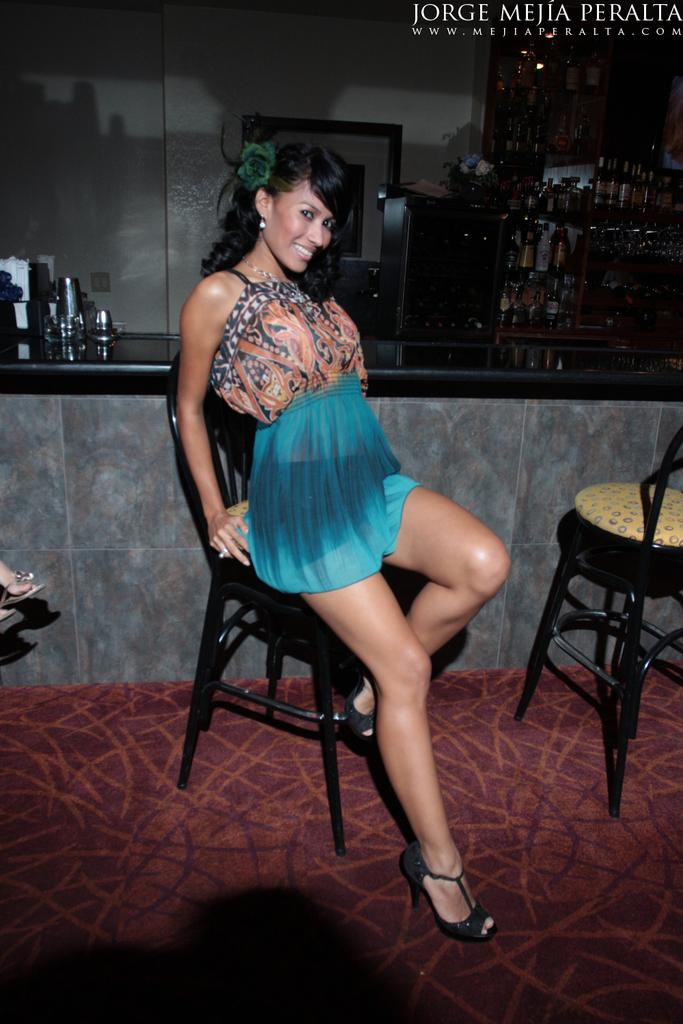Who is the main subject in the image? There is a woman in the image. What is the woman doing in the image? The woman is sitting on a wooden chair and smiling. Where are the wine bottles located in the image? The wine bottles are visible in the image, located on the top right side. What type of judgment is the woman making in the image? There is no indication in the image that the woman is making any judgments. 